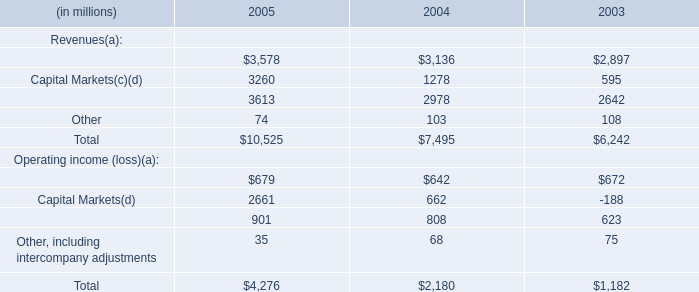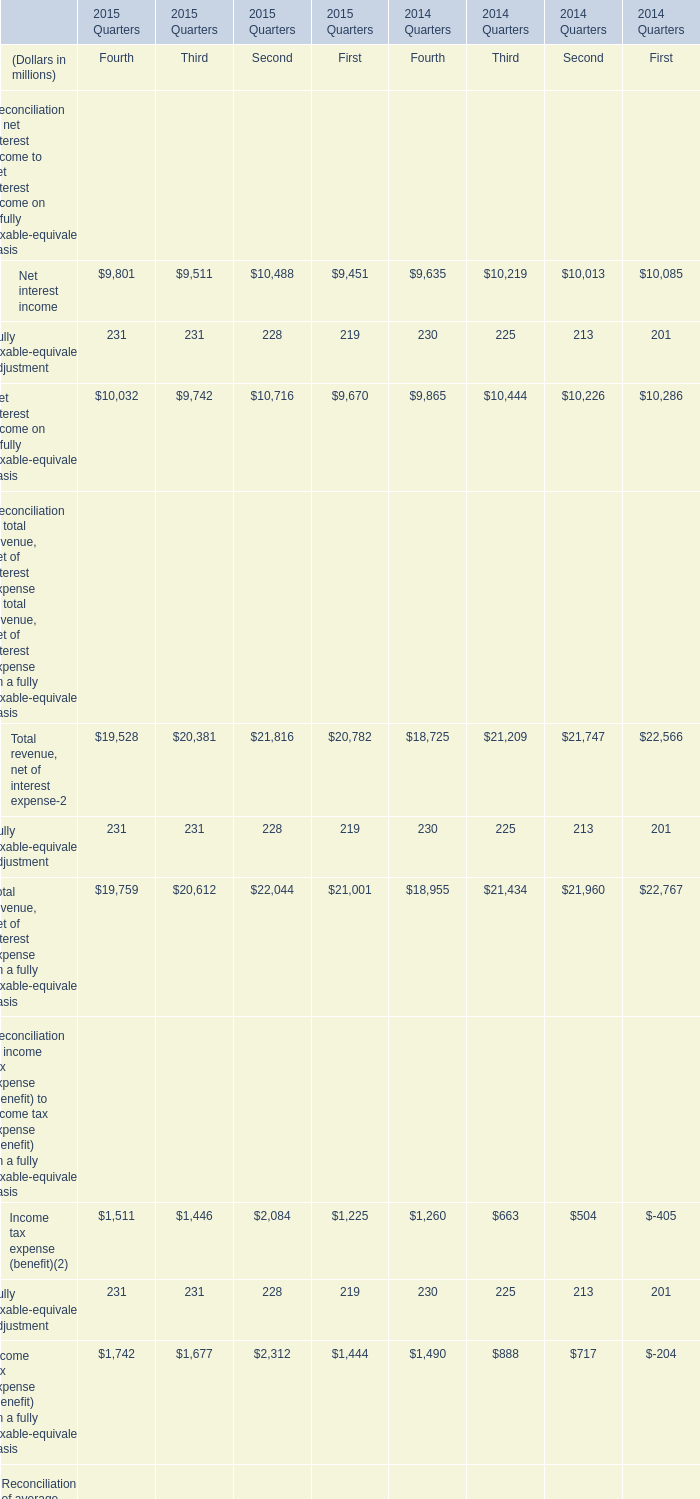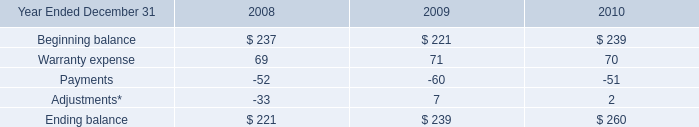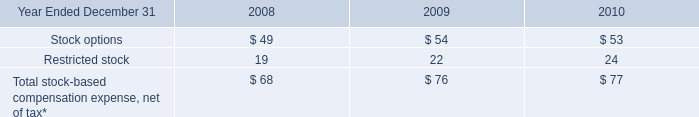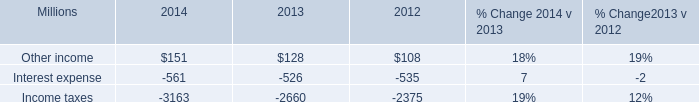assuming an average interest rate of 7% ( 7 % ) , what is the implied composite debt level for 2014 , in millions? 
Computations: (561 / 7%)
Answer: 8014.28571. 